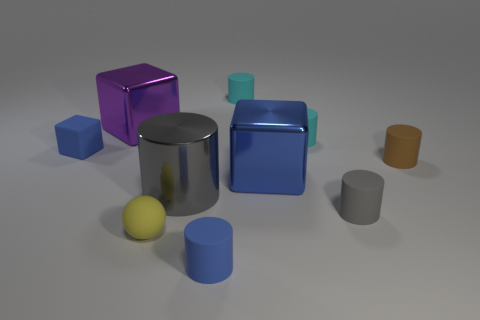How big is the gray object that is to the right of the cylinder in front of the small yellow matte sphere?
Your answer should be compact. Small. There is a matte cylinder that is the same color as the big shiny cylinder; what is its size?
Keep it short and to the point. Small. What number of other objects are there of the same size as the brown rubber object?
Provide a succinct answer. 6. What number of brown cylinders are there?
Make the answer very short. 1. Do the blue cylinder and the metallic cylinder have the same size?
Ensure brevity in your answer.  No. What number of other things are the same shape as the gray matte object?
Give a very brief answer. 5. What is the material of the blue thing that is left of the tiny blue object that is on the right side of the large gray metal cylinder?
Offer a very short reply. Rubber. Are there any rubber cubes to the left of the gray rubber object?
Offer a terse response. Yes. Is the size of the purple block the same as the gray cylinder behind the small gray cylinder?
Your response must be concise. Yes. There is a blue shiny object that is the same shape as the large purple thing; what size is it?
Give a very brief answer. Large. 